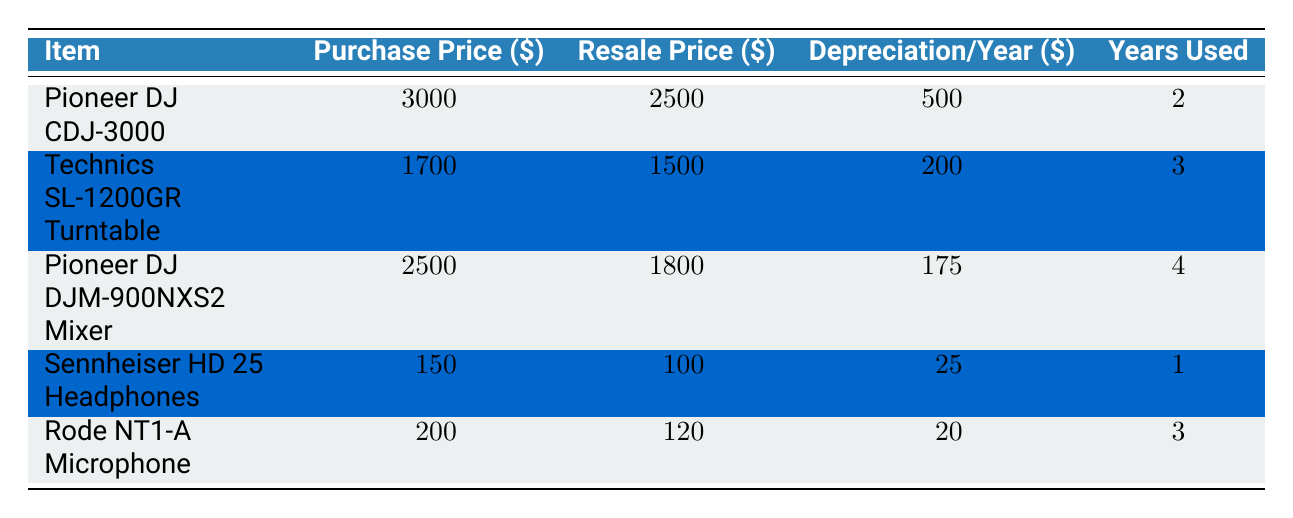What is the resale price of the Pioneer DJ CDJ-3000? The table lists the resale price of the Pioneer DJ CDJ-3000 as 2500.
Answer: 2500 What is the purchase price of the Technics SL-1200GR Turntable? The purchase price for the Technics SL-1200GR Turntable is shown in the table as 1700.
Answer: 1700 How much did the Sennheiser HD 25 Headphones depreciate in total? The table indicates the depreciation per year for the Sennheiser HD 25 Headphones is 25, and since they were used for 1 year, total depreciation is 25 * 1 = 25.
Answer: 25 What is the average depreciation per year for all items listed? To find the average depreciation per year, add the depreciation values: 500 + 200 + 175 + 25 + 20 = 920. Then divide by the number of items (5): 920 / 5 = 184.
Answer: 184 Did the Pioneer DJ DJM-900NXS2 Mixer lose less than 25% of its value upon resale? The purchase price is 2500 and the resale price is 1800. The loss is 2500 - 1800 = 700, which is 700/2500 = 0.28 (28%), thus it did not lose less than 25%.
Answer: No Which item had the greatest percentage loss in value from original purchase to resale? Calculate the percentage loss for each item by using the formula: (Purchase Price - Resale Price) / Purchase Price. The highest percentage is for the Pioneer DJ CDJ-3000: (3000 - 2500) / 3000 = 0.167 (16.7%), which is less than the others. The maximum loss was actually for the Pioneer DJ DJM-900NXS2 Mixer: (2500 - 1800) / 2500 = 0.28 (28%). It had the greatest loss.
Answer: Pioneer DJ DJM-900NXS2 Mixer What is the total resale value of all items combined? Adding up the resale prices: 2500 + 1500 + 1800 + 100 + 120 = 5020 provides the total resale value.
Answer: 5020 Is the purchase price of the Rode NT1-A Microphone more than its resale price? The purchase price is 200 and the resale price is 120. Since 200 is greater than 120, the statement is true.
Answer: Yes How many items had a resale price greater than 1500? By reviewing the table, the only items with resale prices greater than 1500 are the Pioneer DJ CDJ-3000 and the Pioneer DJ DJM-900NXS2 Mixer. Thus, there are 2 items.
Answer: 2 